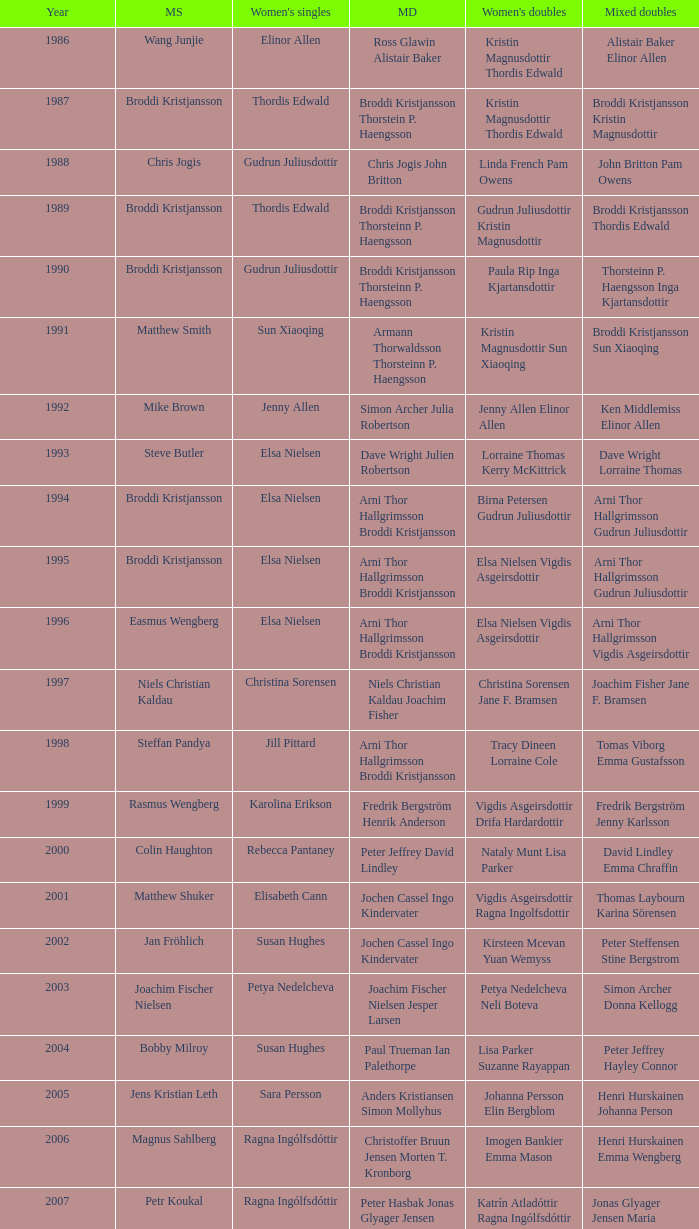Which mixed doubles happened later than 2011? Chou Tien-chen Chiang Mei-hui. 